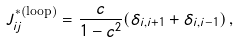Convert formula to latex. <formula><loc_0><loc_0><loc_500><loc_500>J _ { i j } ^ { * \text {(loop)} } = \frac { c } { 1 - c ^ { 2 } } ( \delta _ { i , i + 1 } + \delta _ { i , i - 1 } ) \, ,</formula> 